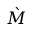<formula> <loc_0><loc_0><loc_500><loc_500>\grave { M }</formula> 